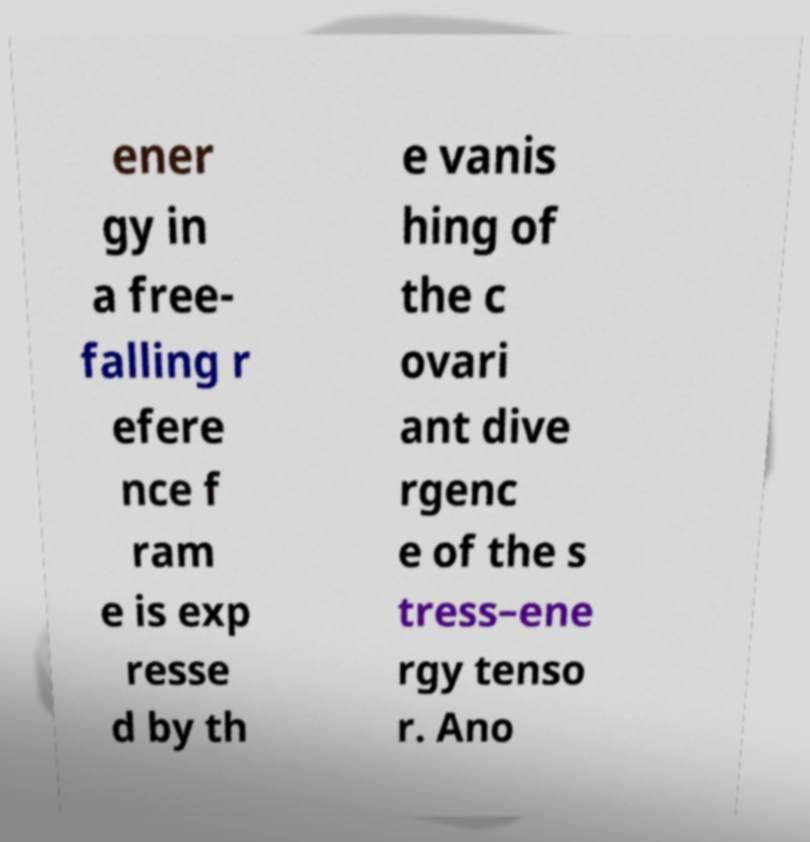For documentation purposes, I need the text within this image transcribed. Could you provide that? ener gy in a free- falling r efere nce f ram e is exp resse d by th e vanis hing of the c ovari ant dive rgenc e of the s tress–ene rgy tenso r. Ano 